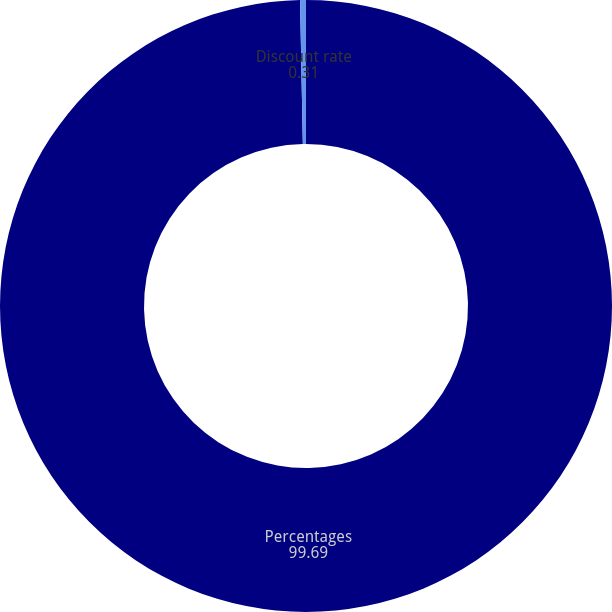<chart> <loc_0><loc_0><loc_500><loc_500><pie_chart><fcel>Percentages<fcel>Discount rate<nl><fcel>99.69%<fcel>0.31%<nl></chart> 